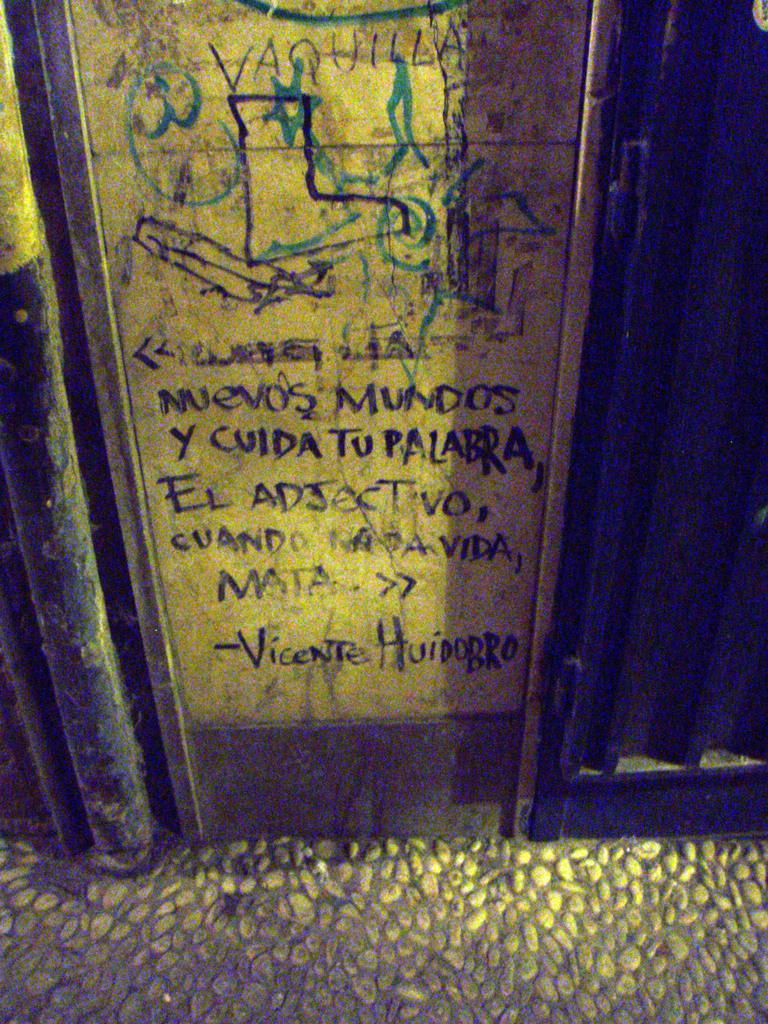How would you summarize this image in a sentence or two? Here we can see a board. And this is floor with pebbles. 